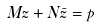Convert formula to latex. <formula><loc_0><loc_0><loc_500><loc_500>M z + N \bar { z } = p</formula> 